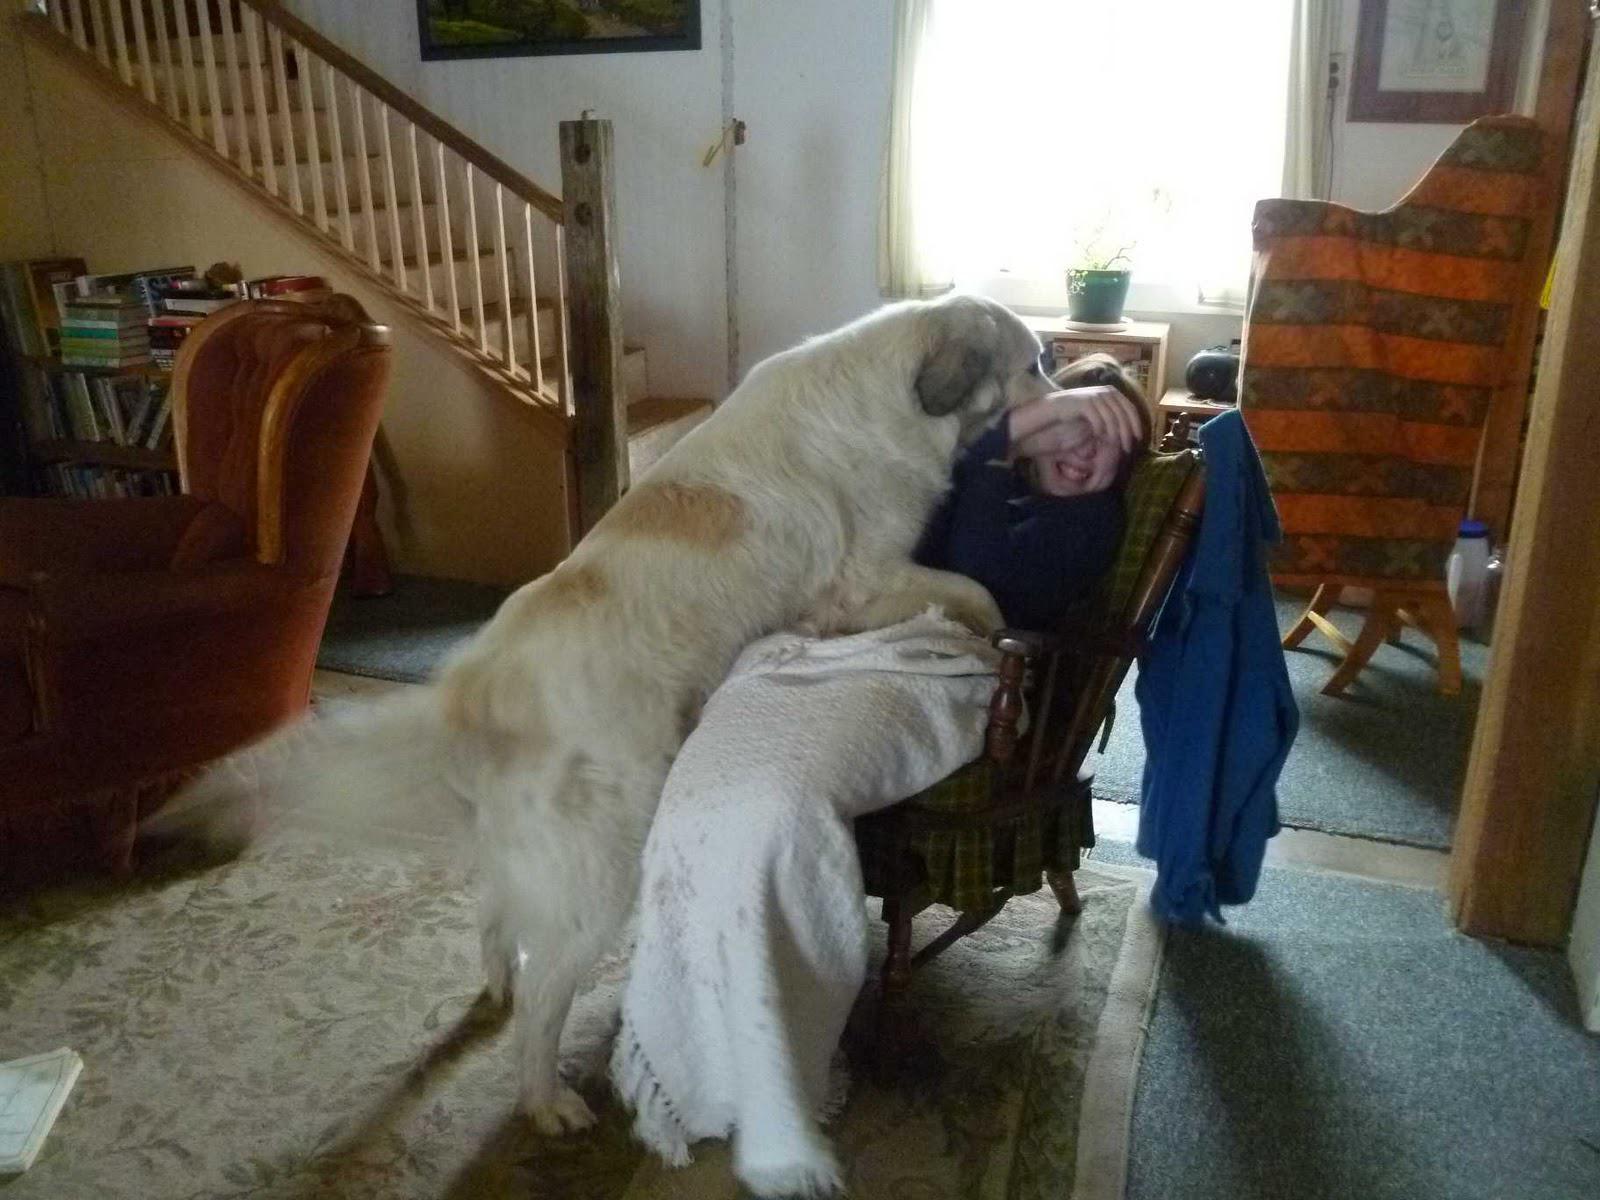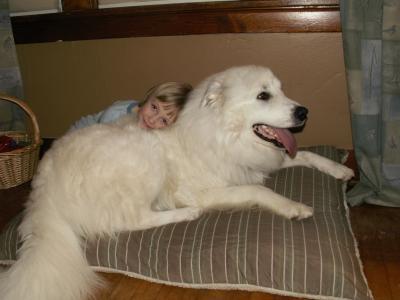The first image is the image on the left, the second image is the image on the right. Examine the images to the left and right. Is the description "Each image shows one person in an indoors setting with a large dog." accurate? Answer yes or no. Yes. The first image is the image on the left, the second image is the image on the right. Evaluate the accuracy of this statement regarding the images: "An image shows exactly one person behind two white dogs.". Is it true? Answer yes or no. No. 